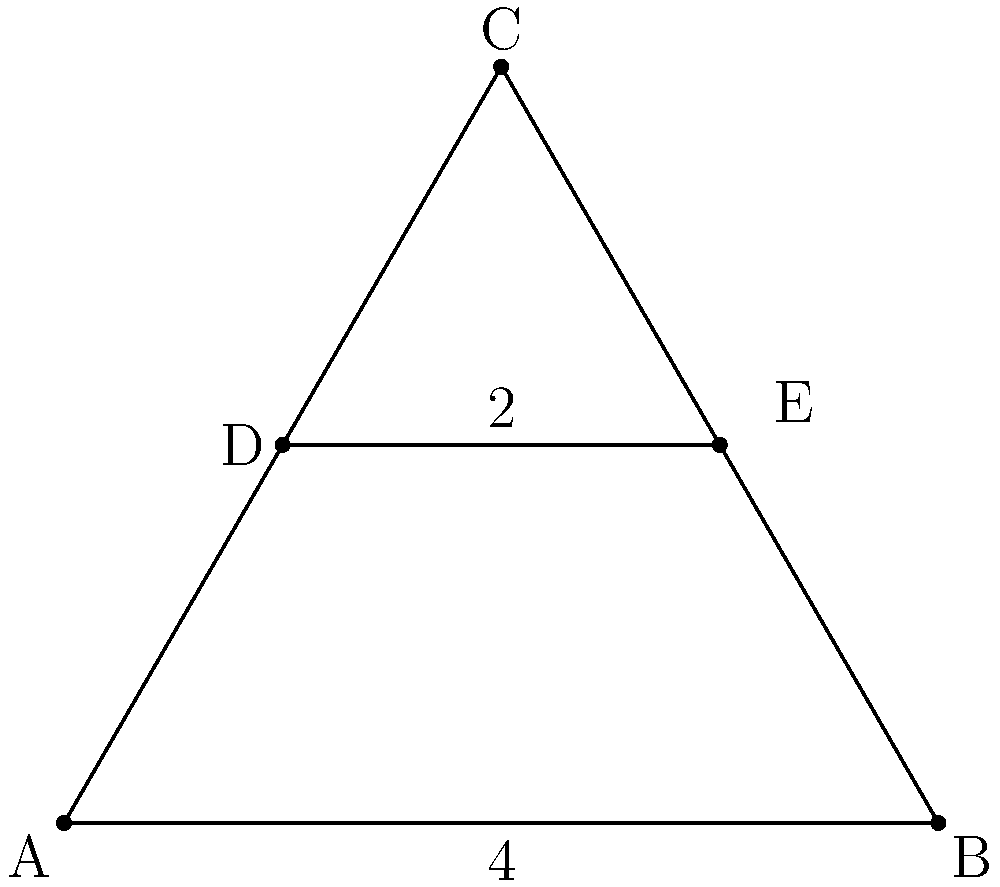In designing an efficient drone formation pattern, you propose a triangular shape with a connecting line inside. If the base of the triangle is 4 units long and the connecting line is 2 units long, what is the area of the upper portion of the triangle (above the connecting line) in square units? To solve this problem, we'll follow these steps:

1) First, we need to determine the height of the triangle. We can do this using the Pythagorean theorem.

2) Let's call the height of the triangle $h$. Half of the base is 2 units. So we have:

   $h^2 + 2^2 = (\frac{4}{2})^2$
   $h^2 + 4 = 4$
   $h^2 = 4 - 4 = 0$
   $h = \sqrt{0} = 0$

3) The height of the full triangle is $\sqrt{3} \approx 1.73$ units.

4) Now, we need to find the height of the upper portion. It's the difference between the full height and the height of the lower portion:

   $\sqrt{3} - \frac{\sqrt{3}}{2} = \frac{\sqrt{3}}{2} \approx 0.87$ units

5) The area of a triangle is given by the formula: $A = \frac{1}{2} * base * height$

6) For the upper portion:
   $A = \frac{1}{2} * 4 * \frac{\sqrt{3}}{2} = \sqrt{3} \approx 1.73$ square units

Therefore, the area of the upper portion of the triangle is $\sqrt{3}$ square units.
Answer: $\sqrt{3}$ square units 